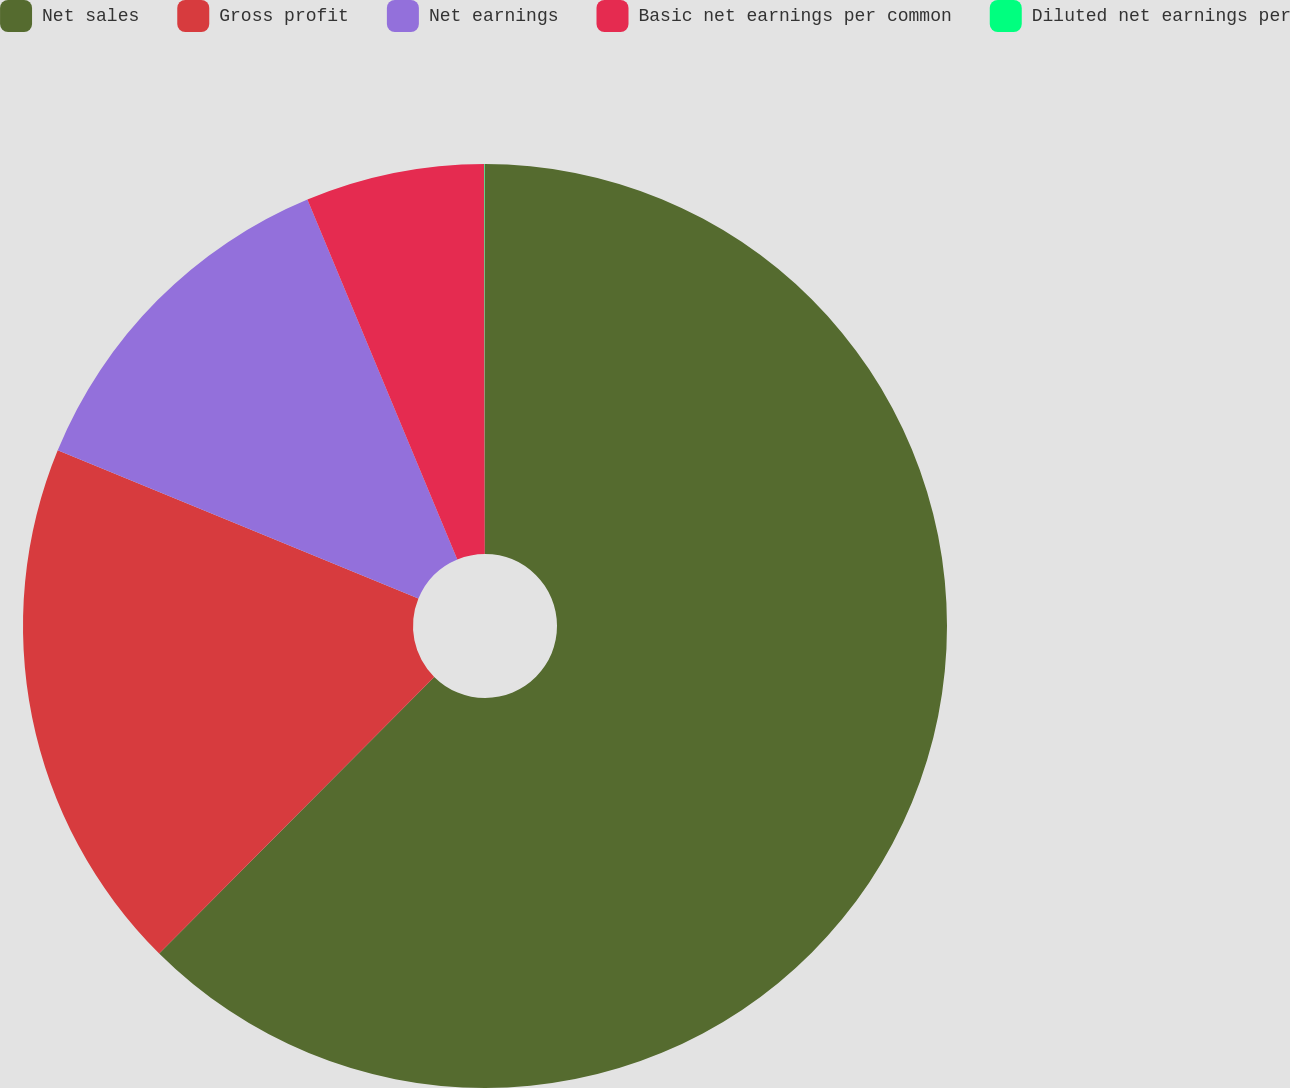Convert chart. <chart><loc_0><loc_0><loc_500><loc_500><pie_chart><fcel>Net sales<fcel>Gross profit<fcel>Net earnings<fcel>Basic net earnings per common<fcel>Diluted net earnings per<nl><fcel>62.46%<fcel>18.75%<fcel>12.51%<fcel>6.26%<fcel>0.02%<nl></chart> 